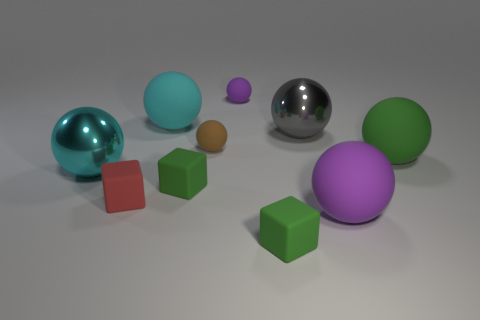What is the material of the cyan ball that is the same size as the cyan matte thing?
Give a very brief answer. Metal. Is the size of the cyan ball that is to the right of the cyan shiny ball the same as the purple sphere that is in front of the cyan metal object?
Offer a terse response. Yes. There is a purple ball behind the tiny green matte block that is behind the purple rubber sphere that is to the right of the gray object; what is its size?
Keep it short and to the point. Small. What shape is the thing that is right of the purple matte object that is in front of the green matte sphere?
Your answer should be very brief. Sphere. What color is the big object that is left of the brown ball and to the right of the cyan metal ball?
Your response must be concise. Cyan. Is there a gray ball made of the same material as the large green object?
Make the answer very short. No. The brown rubber ball has what size?
Provide a succinct answer. Small. There is a metal sphere that is to the right of the cyan thing that is behind the gray ball; how big is it?
Your answer should be very brief. Large. There is a gray object that is the same shape as the brown rubber object; what is it made of?
Offer a terse response. Metal. What number of large gray balls are there?
Offer a very short reply. 1. 